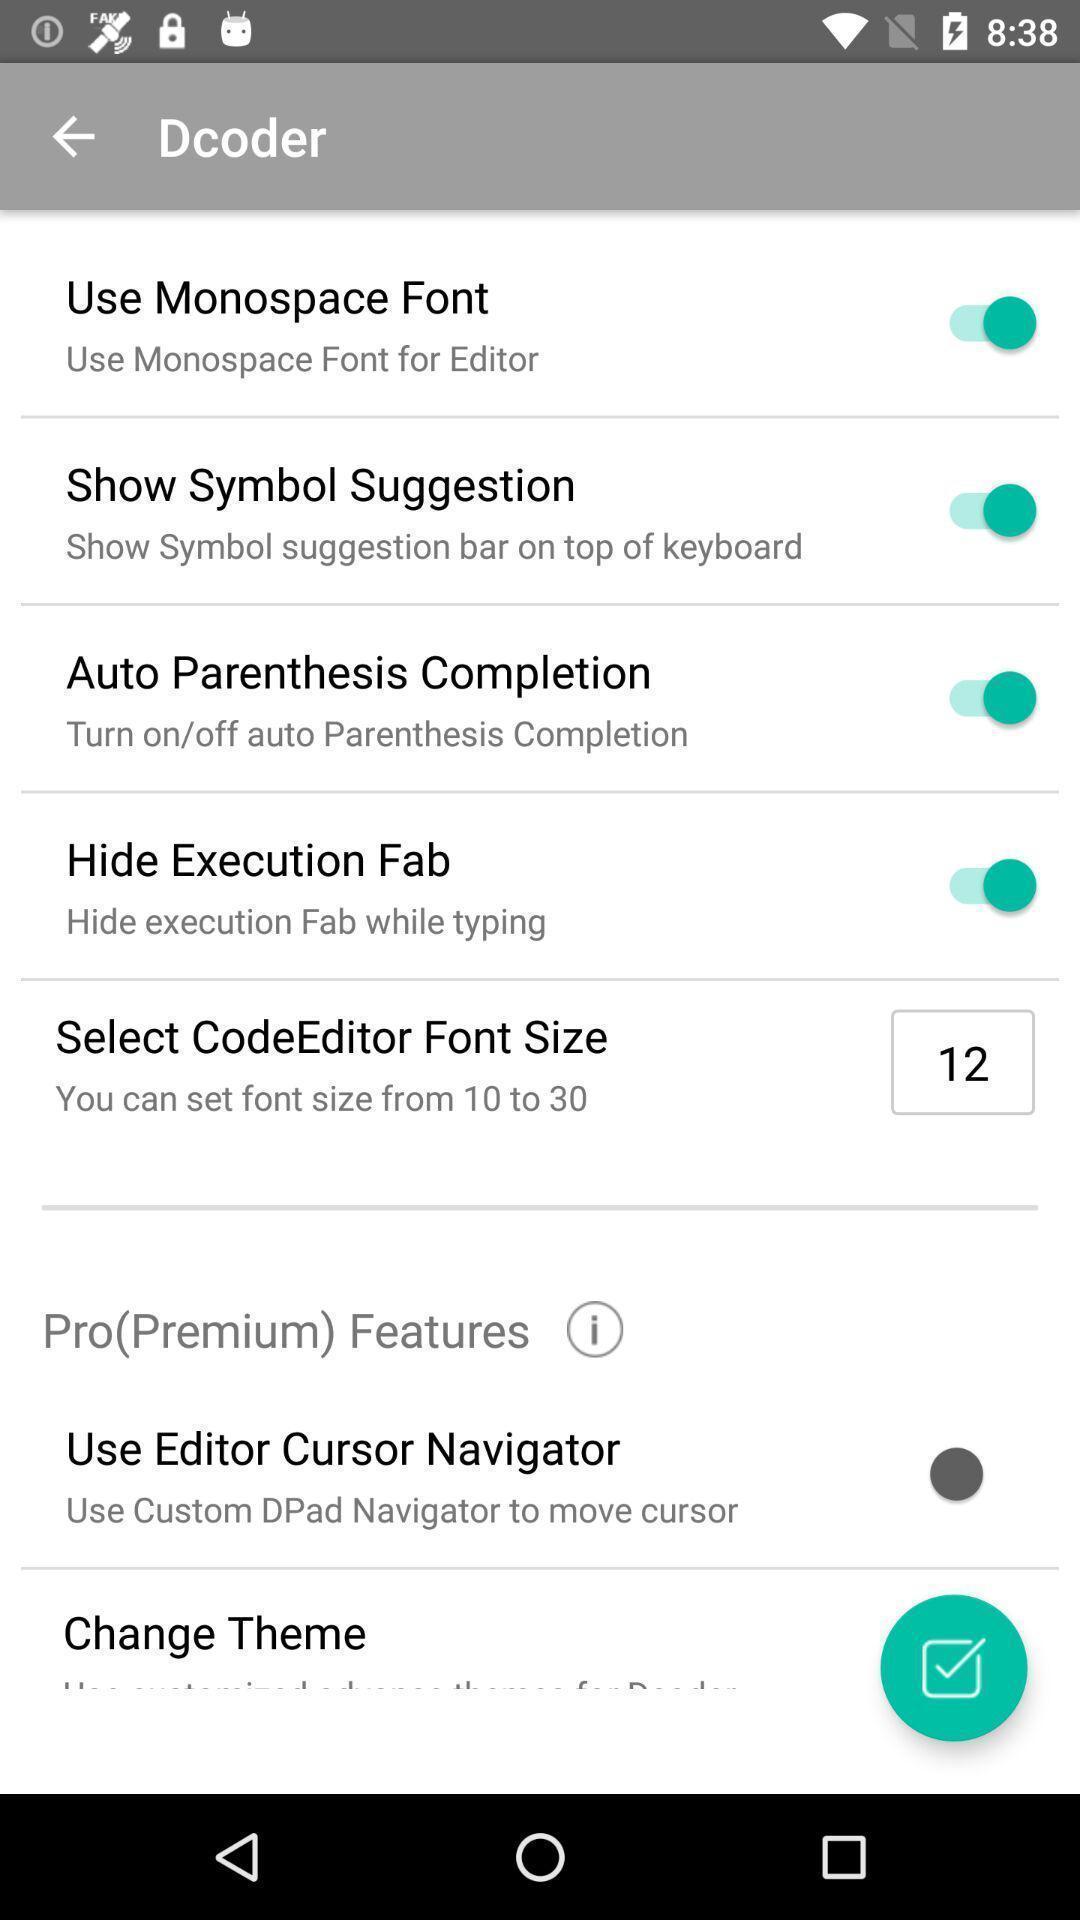Explain the elements present in this screenshot. Page showing pro premium features options. 